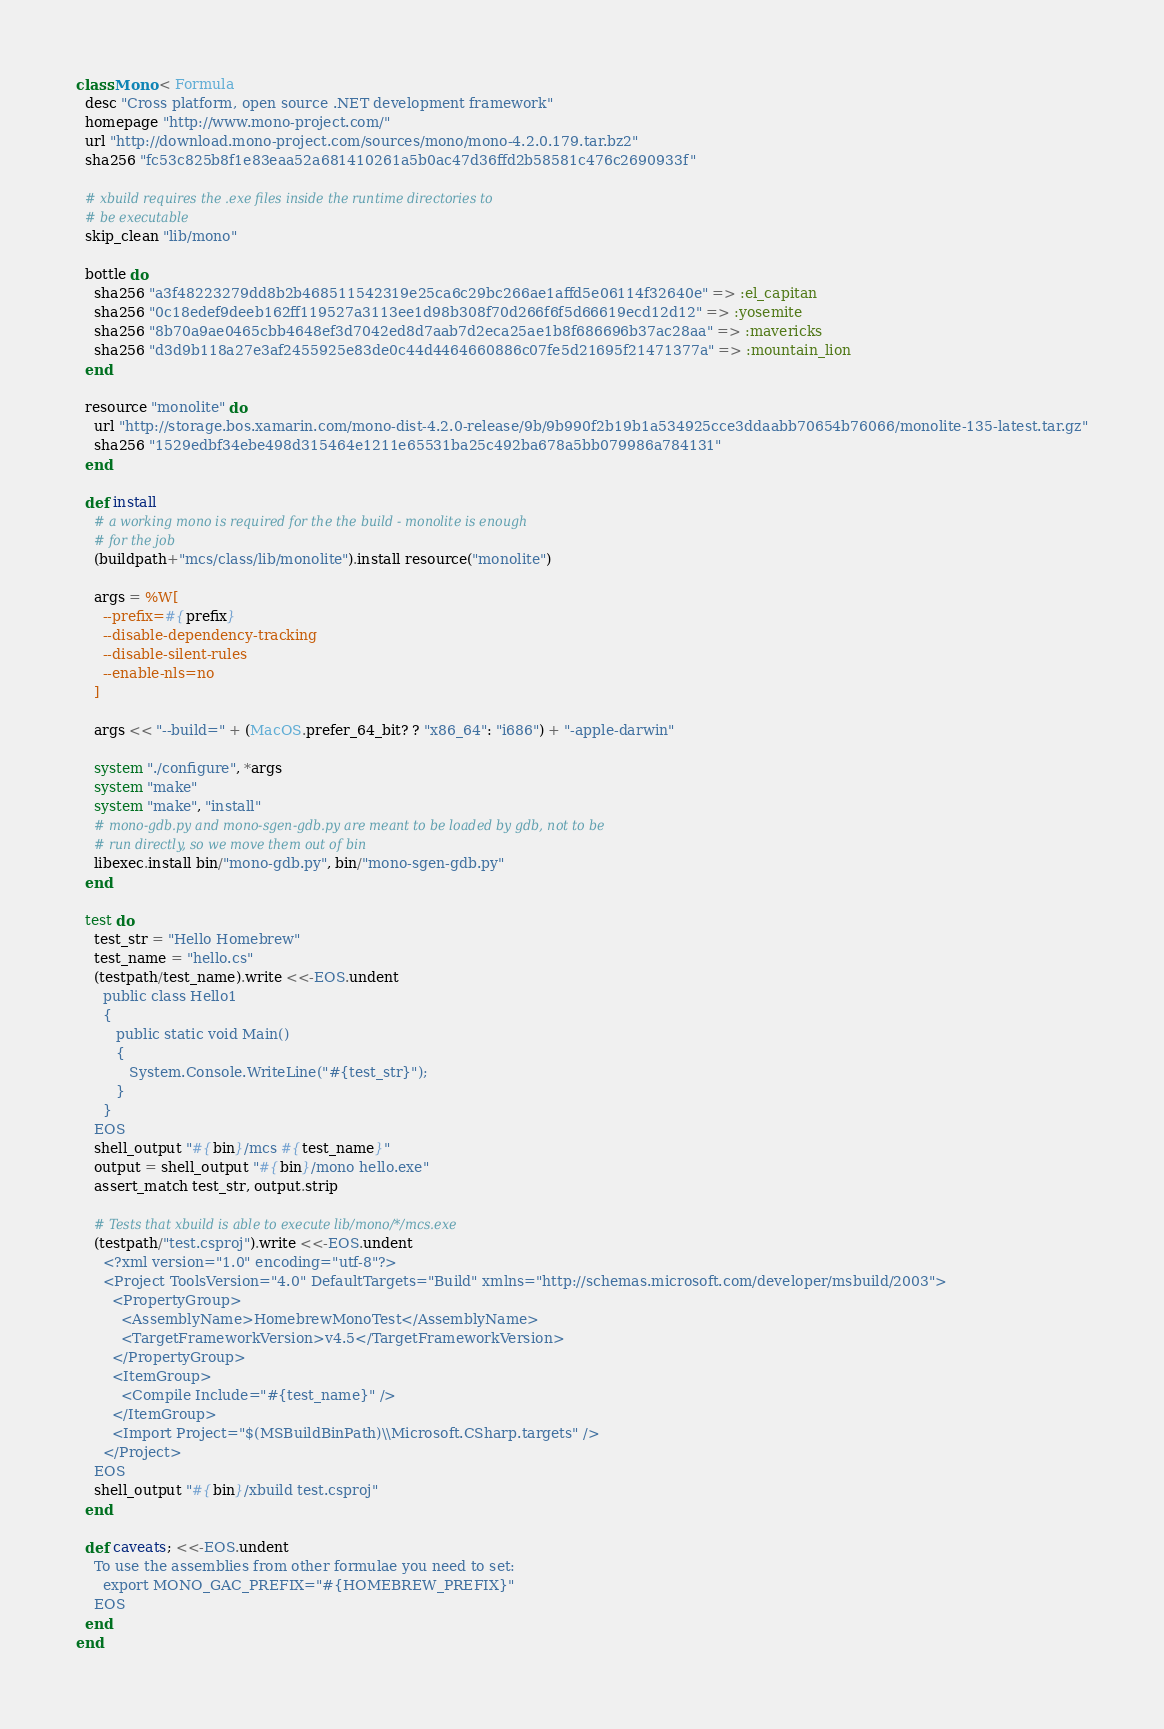Convert code to text. <code><loc_0><loc_0><loc_500><loc_500><_Ruby_>class Mono < Formula
  desc "Cross platform, open source .NET development framework"
  homepage "http://www.mono-project.com/"
  url "http://download.mono-project.com/sources/mono/mono-4.2.0.179.tar.bz2"
  sha256 "fc53c825b8f1e83eaa52a681410261a5b0ac47d36ffd2b58581c476c2690933f"

  # xbuild requires the .exe files inside the runtime directories to
  # be executable
  skip_clean "lib/mono"

  bottle do
    sha256 "a3f48223279dd8b2b468511542319e25ca6c29bc266ae1affd5e06114f32640e" => :el_capitan
    sha256 "0c18edef9deeb162ff119527a3113ee1d98b308f70d266f6f5d66619ecd12d12" => :yosemite
    sha256 "8b70a9ae0465cbb4648ef3d7042ed8d7aab7d2eca25ae1b8f686696b37ac28aa" => :mavericks
    sha256 "d3d9b118a27e3af2455925e83de0c44d4464660886c07fe5d21695f21471377a" => :mountain_lion
  end

  resource "monolite" do
    url "http://storage.bos.xamarin.com/mono-dist-4.2.0-release/9b/9b990f2b19b1a534925cce3ddaabb70654b76066/monolite-135-latest.tar.gz"
    sha256 "1529edbf34ebe498d315464e1211e65531ba25c492ba678a5bb079986a784131"
  end

  def install
    # a working mono is required for the the build - monolite is enough
    # for the job
    (buildpath+"mcs/class/lib/monolite").install resource("monolite")

    args = %W[
      --prefix=#{prefix}
      --disable-dependency-tracking
      --disable-silent-rules
      --enable-nls=no
    ]

    args << "--build=" + (MacOS.prefer_64_bit? ? "x86_64": "i686") + "-apple-darwin"

    system "./configure", *args
    system "make"
    system "make", "install"
    # mono-gdb.py and mono-sgen-gdb.py are meant to be loaded by gdb, not to be
    # run directly, so we move them out of bin
    libexec.install bin/"mono-gdb.py", bin/"mono-sgen-gdb.py"
  end

  test do
    test_str = "Hello Homebrew"
    test_name = "hello.cs"
    (testpath/test_name).write <<-EOS.undent
      public class Hello1
      {
         public static void Main()
         {
            System.Console.WriteLine("#{test_str}");
         }
      }
    EOS
    shell_output "#{bin}/mcs #{test_name}"
    output = shell_output "#{bin}/mono hello.exe"
    assert_match test_str, output.strip

    # Tests that xbuild is able to execute lib/mono/*/mcs.exe
    (testpath/"test.csproj").write <<-EOS.undent
      <?xml version="1.0" encoding="utf-8"?>
      <Project ToolsVersion="4.0" DefaultTargets="Build" xmlns="http://schemas.microsoft.com/developer/msbuild/2003">
        <PropertyGroup>
          <AssemblyName>HomebrewMonoTest</AssemblyName>
          <TargetFrameworkVersion>v4.5</TargetFrameworkVersion>
        </PropertyGroup>
        <ItemGroup>
          <Compile Include="#{test_name}" />
        </ItemGroup>
        <Import Project="$(MSBuildBinPath)\\Microsoft.CSharp.targets" />
      </Project>
    EOS
    shell_output "#{bin}/xbuild test.csproj"
  end

  def caveats; <<-EOS.undent
    To use the assemblies from other formulae you need to set:
      export MONO_GAC_PREFIX="#{HOMEBREW_PREFIX}"
    EOS
  end
end
</code> 